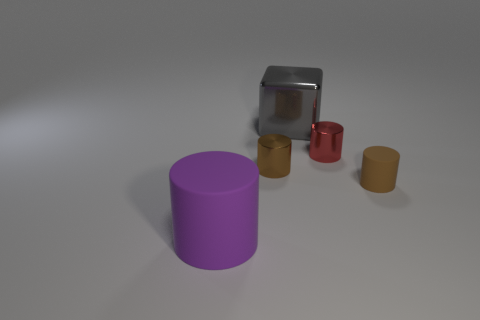What colors are the objects in this image and what material do they appear to be made of? In the image, we see objects with various colors and materials. Starting from the left, there's a large purple object that seems to be made of rubber. The large cube in the center appears to be made of a shiny material, likely metal, and is gray in color. In the background, we see a smaller red object and a tiny yellow one, both seemingly made of rubber. Lastly, there's a brown object on the right, which also appears rubbery in nature. 